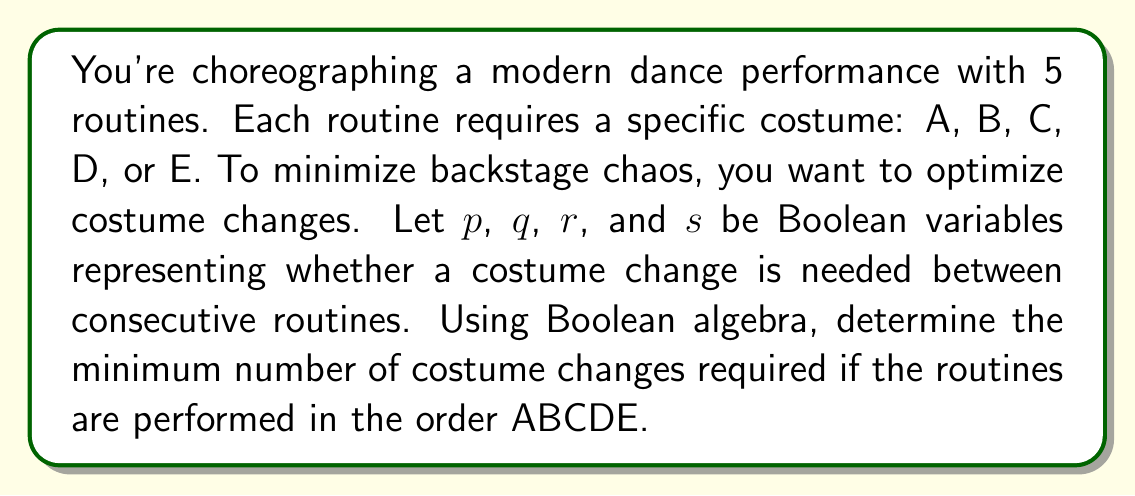Solve this math problem. Let's approach this step-by-step:

1) Define Boolean variables:
   $p$ = change needed between 1st and 2nd routines (A to B)
   $q$ = change needed between 2nd and 3rd routines (B to C)
   $r$ = change needed between 3rd and 4th routines (C to D)
   $s$ = change needed between 4th and 5th routines (D to E)

2) Analyze each transition:
   A to B: Different costumes, so $p = 1$
   B to C: Different costumes, so $q = 1$
   C to D: Different costumes, so $r = 1$
   D to E: Different costumes, so $s = 1$

3) Express the total number of changes as a Boolean function:
   $f(p,q,r,s) = p + q + r + s$

4) Substitute the known values:
   $f(1,1,1,1) = 1 + 1 + 1 + 1 = 4$

5) In Boolean algebra, this sum represents the number of 1's in the expression, which corresponds to the number of costume changes required.

Therefore, the minimum number of costume changes required is 4.
Answer: 4 